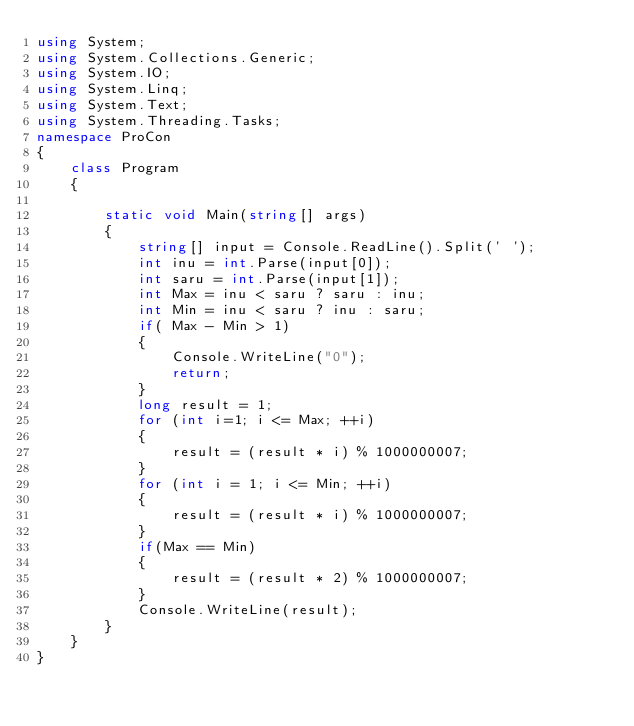<code> <loc_0><loc_0><loc_500><loc_500><_C#_>using System;
using System.Collections.Generic;
using System.IO;
using System.Linq;
using System.Text;
using System.Threading.Tasks;
namespace ProCon
{
    class Program
    {

        static void Main(string[] args)
        {
            string[] input = Console.ReadLine().Split(' ');
            int inu = int.Parse(input[0]);
            int saru = int.Parse(input[1]);
            int Max = inu < saru ? saru : inu;
            int Min = inu < saru ? inu : saru;
            if( Max - Min > 1)
            {
                Console.WriteLine("0");
                return;
            }
            long result = 1;      
            for (int i=1; i <= Max; ++i)
            {
                result = (result * i) % 1000000007;
            }
            for (int i = 1; i <= Min; ++i)
            {
                result = (result * i) % 1000000007;
            }
            if(Max == Min)
            {
                result = (result * 2) % 1000000007;
            }
            Console.WriteLine(result);
        }
    }
}
</code> 